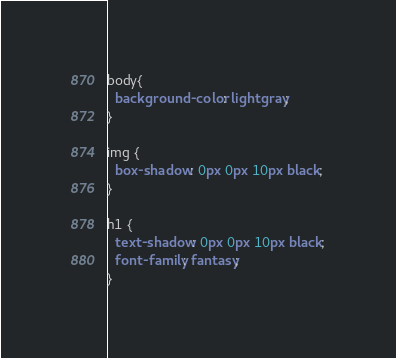Convert code to text. <code><loc_0><loc_0><loc_500><loc_500><_CSS_>body{
  background-color: lightgray;
}

img {
  box-shadow: 0px 0px 10px black;
}

h1 {
  text-shadow: 0px 0px 10px black;
  font-family: fantasy;
}
</code> 